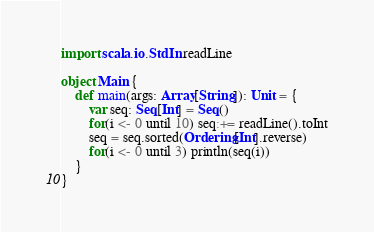<code> <loc_0><loc_0><loc_500><loc_500><_Scala_>import scala.io.StdIn.readLine

object Main {
    def main(args: Array[String]): Unit = { 
        var seq: Seq[Int] = Seq()
        for(i <- 0 until 10) seq:+= readLine().toInt
        seq = seq.sorted(Ordering[Int].reverse)
        for(i <- 0 until 3) println(seq(i))
    }   
}</code> 